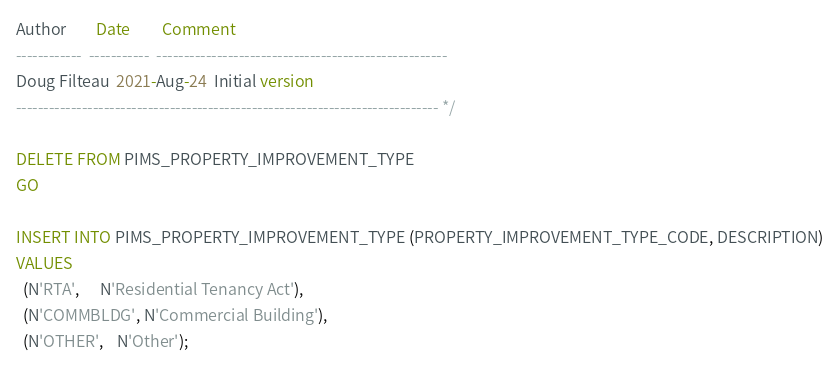<code> <loc_0><loc_0><loc_500><loc_500><_SQL_>Author        Date         Comment
------------  -----------  -----------------------------------------------------
Doug Filteau  2021-Aug-24  Initial version
----------------------------------------------------------------------------- */

DELETE FROM PIMS_PROPERTY_IMPROVEMENT_TYPE
GO

INSERT INTO PIMS_PROPERTY_IMPROVEMENT_TYPE (PROPERTY_IMPROVEMENT_TYPE_CODE, DESCRIPTION)
VALUES
  (N'RTA',      N'Residential Tenancy Act'),
  (N'COMMBLDG', N'Commercial Building'),
  (N'OTHER',    N'Other');</code> 